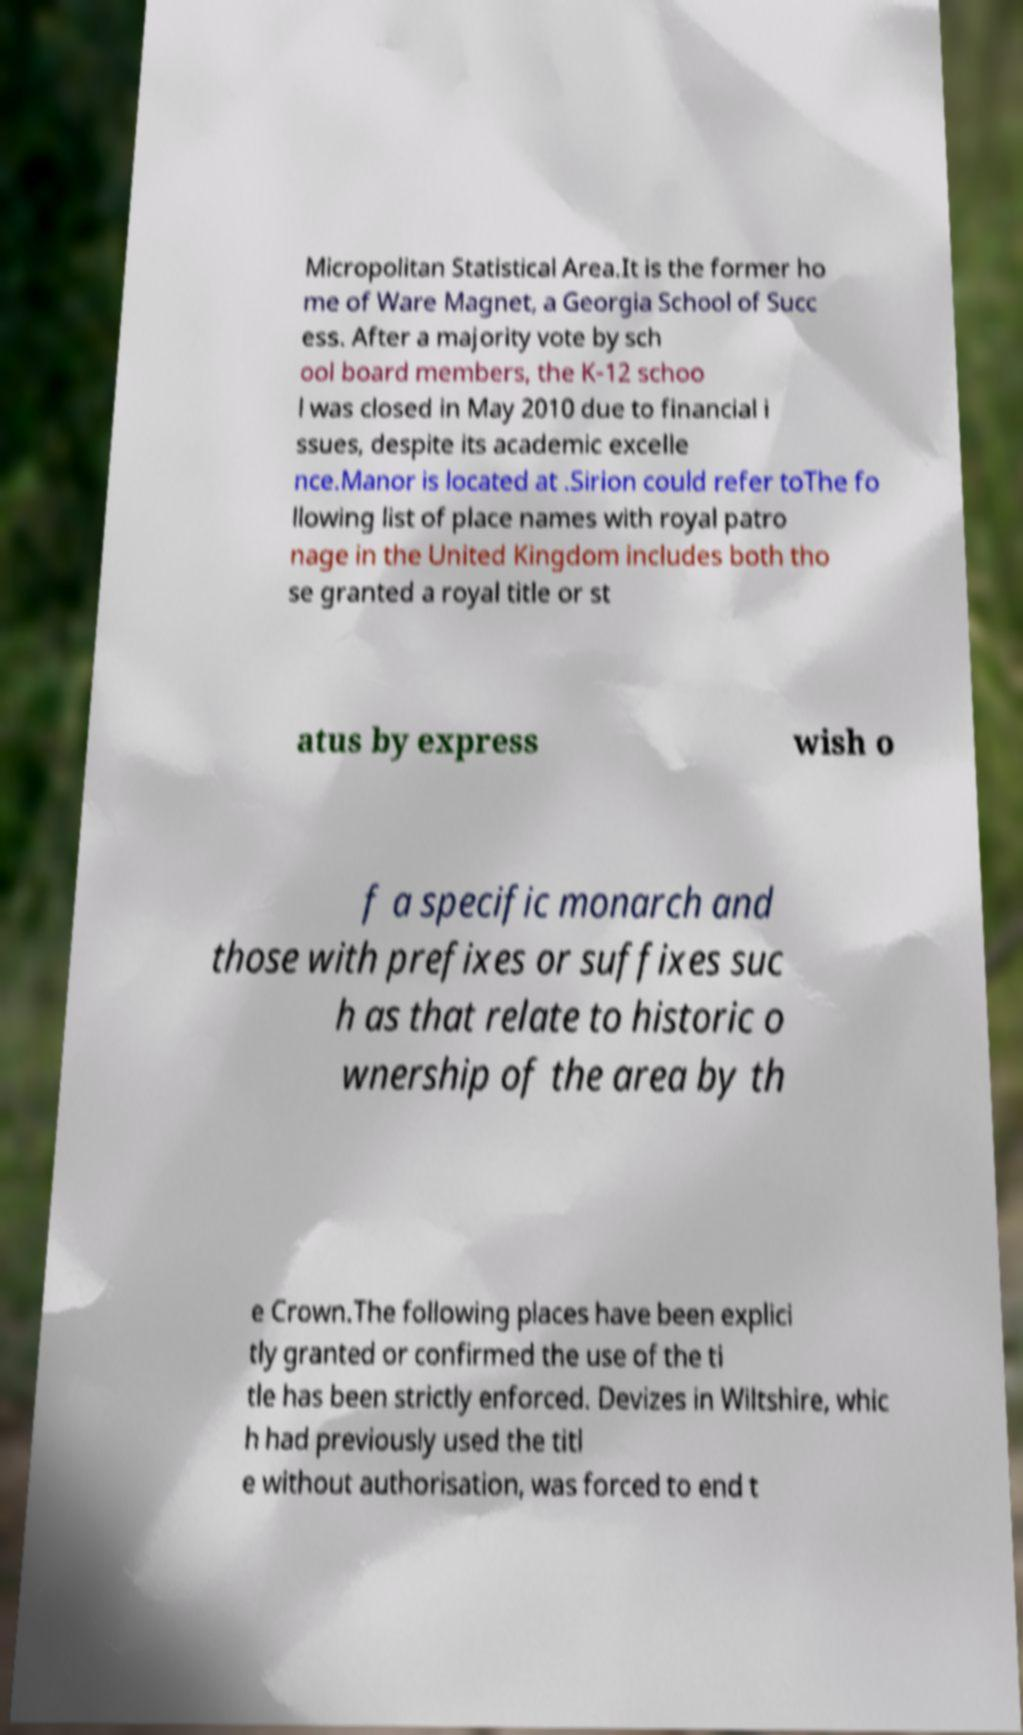I need the written content from this picture converted into text. Can you do that? Micropolitan Statistical Area.It is the former ho me of Ware Magnet, a Georgia School of Succ ess. After a majority vote by sch ool board members, the K-12 schoo l was closed in May 2010 due to financial i ssues, despite its academic excelle nce.Manor is located at .Sirion could refer toThe fo llowing list of place names with royal patro nage in the United Kingdom includes both tho se granted a royal title or st atus by express wish o f a specific monarch and those with prefixes or suffixes suc h as that relate to historic o wnership of the area by th e Crown.The following places have been explici tly granted or confirmed the use of the ti tle has been strictly enforced. Devizes in Wiltshire, whic h had previously used the titl e without authorisation, was forced to end t 